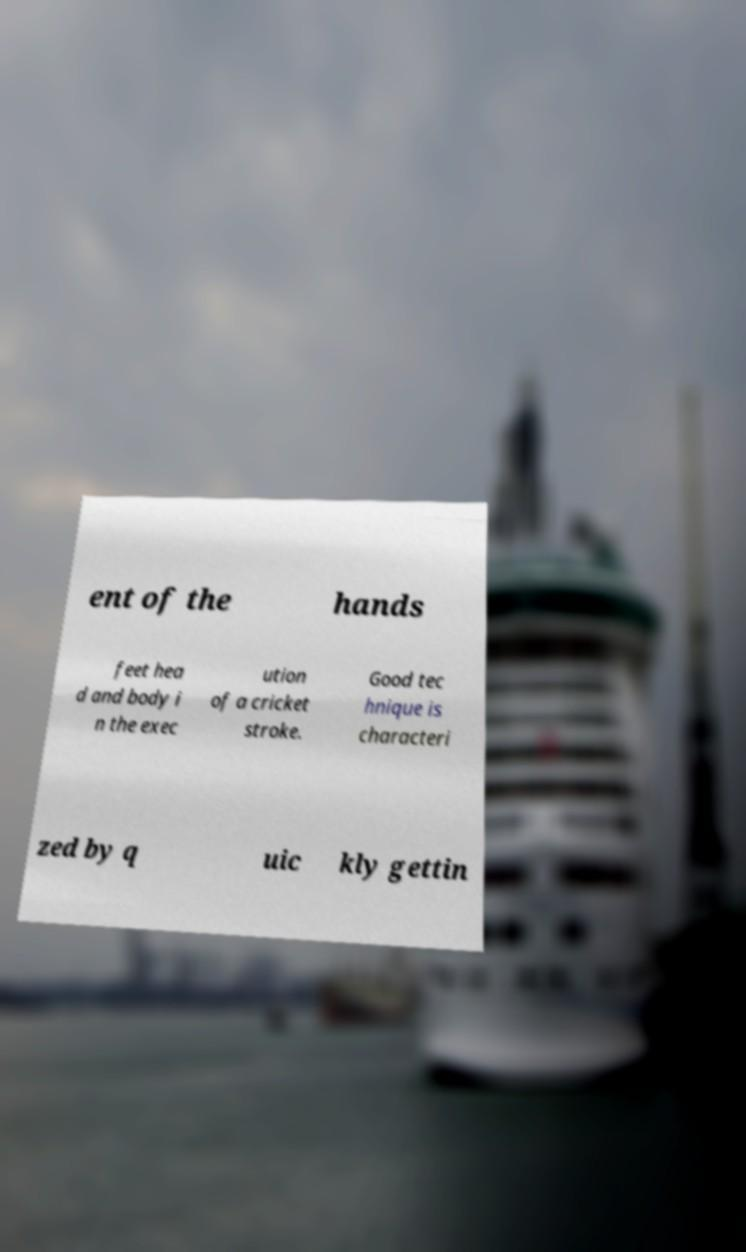I need the written content from this picture converted into text. Can you do that? ent of the hands feet hea d and body i n the exec ution of a cricket stroke. Good tec hnique is characteri zed by q uic kly gettin 